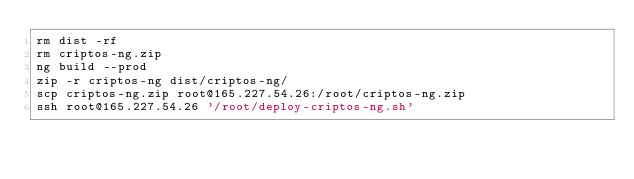<code> <loc_0><loc_0><loc_500><loc_500><_Bash_>rm dist -rf
rm criptos-ng.zip
ng build --prod 
zip -r criptos-ng dist/criptos-ng/
scp criptos-ng.zip root@165.227.54.26:/root/criptos-ng.zip
ssh root@165.227.54.26 '/root/deploy-criptos-ng.sh'
</code> 